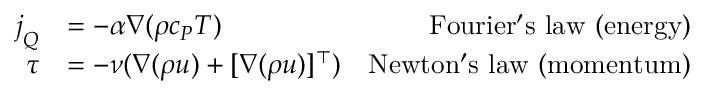Convert formula to latex. <formula><loc_0><loc_0><loc_500><loc_500>\begin{array} { r l r } { j _ { Q } } & { = - \alpha \nabla ( \rho c _ { P } T ) } & { F o u r i e r ^ { \prime } s l a w ( e n e r g y ) } \\ { \tau } & { = - \nu ( \nabla ( \rho u ) + [ \nabla ( \rho u ) ] ^ { \top } ) } & { N e w t o n ^ { \prime } s l a w ( m o m e n t u m ) } \end{array}</formula> 